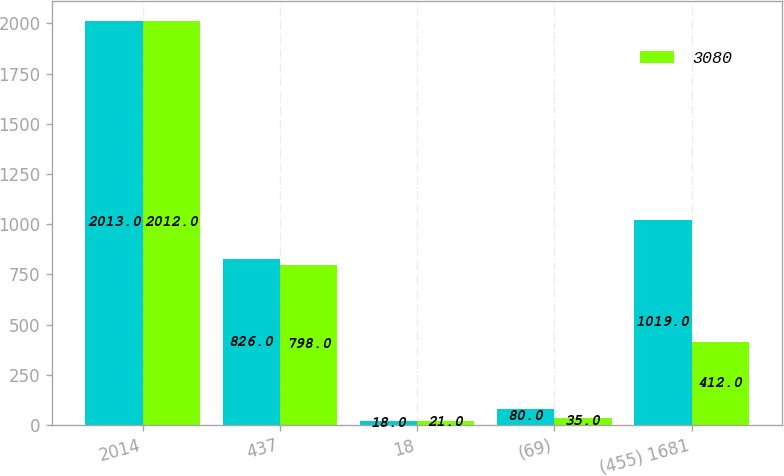Convert chart to OTSL. <chart><loc_0><loc_0><loc_500><loc_500><stacked_bar_chart><ecel><fcel>2014<fcel>437<fcel>18<fcel>(69)<fcel>(455) 1681<nl><fcel>nan<fcel>2013<fcel>826<fcel>18<fcel>80<fcel>1019<nl><fcel>3080<fcel>2012<fcel>798<fcel>21<fcel>35<fcel>412<nl></chart> 